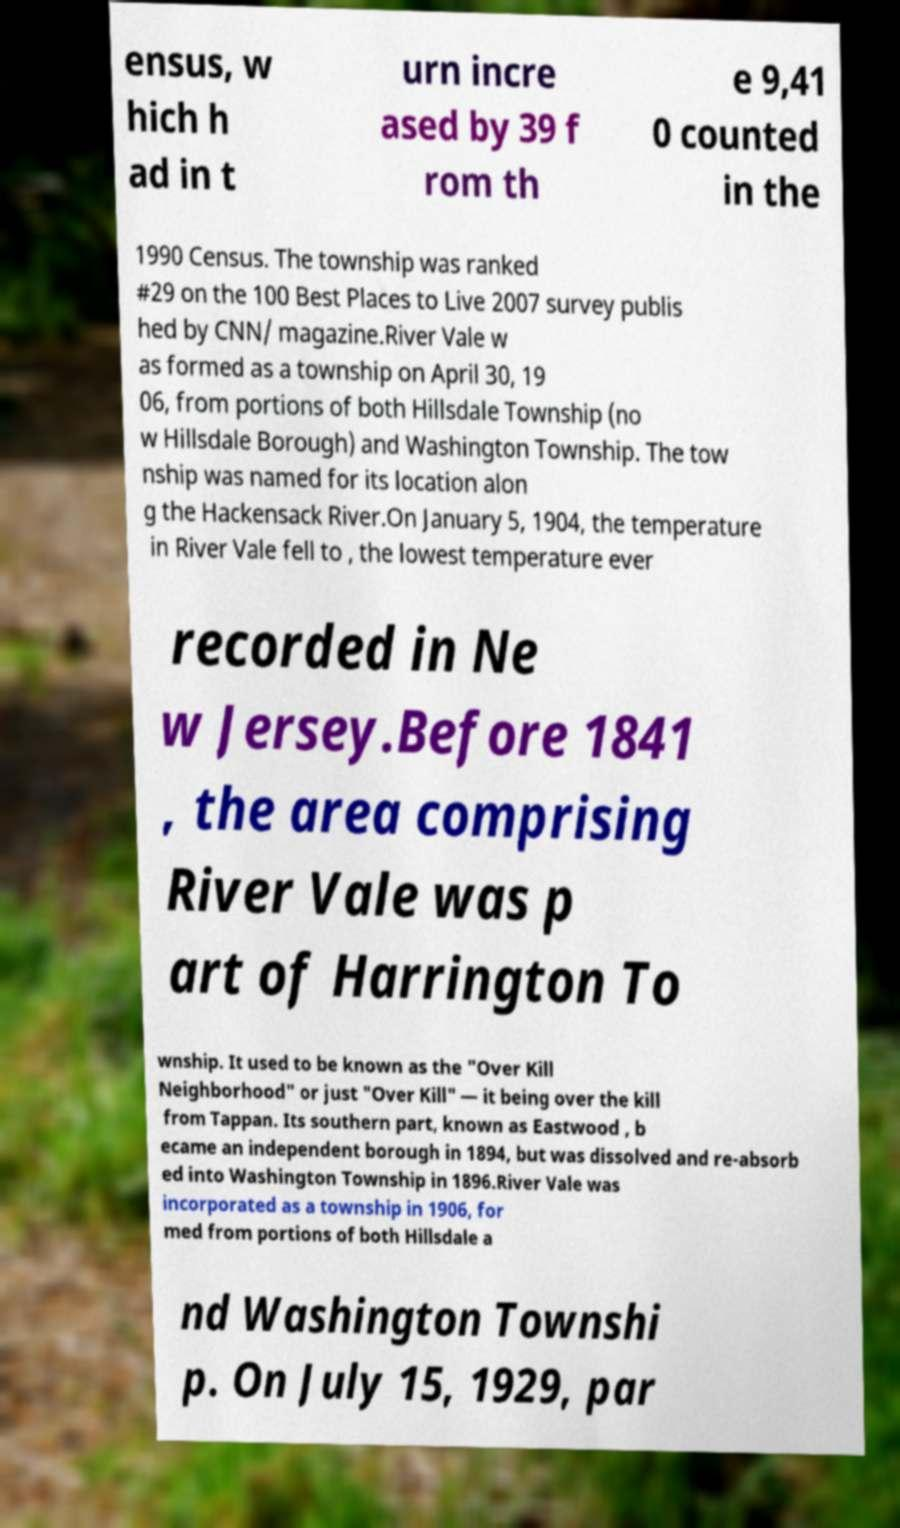What messages or text are displayed in this image? I need them in a readable, typed format. ensus, w hich h ad in t urn incre ased by 39 f rom th e 9,41 0 counted in the 1990 Census. The township was ranked #29 on the 100 Best Places to Live 2007 survey publis hed by CNN/ magazine.River Vale w as formed as a township on April 30, 19 06, from portions of both Hillsdale Township (no w Hillsdale Borough) and Washington Township. The tow nship was named for its location alon g the Hackensack River.On January 5, 1904, the temperature in River Vale fell to , the lowest temperature ever recorded in Ne w Jersey.Before 1841 , the area comprising River Vale was p art of Harrington To wnship. It used to be known as the "Over Kill Neighborhood" or just "Over Kill" — it being over the kill from Tappan. Its southern part, known as Eastwood , b ecame an independent borough in 1894, but was dissolved and re-absorb ed into Washington Township in 1896.River Vale was incorporated as a township in 1906, for med from portions of both Hillsdale a nd Washington Townshi p. On July 15, 1929, par 